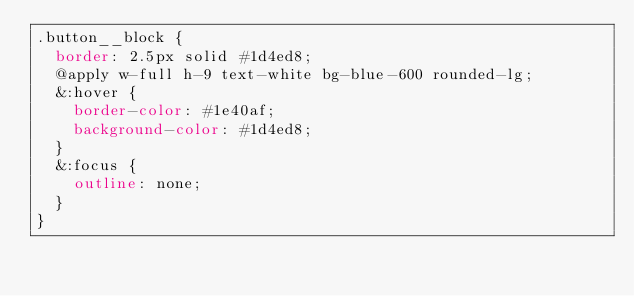<code> <loc_0><loc_0><loc_500><loc_500><_CSS_>.button__block {
  border: 2.5px solid #1d4ed8;
  @apply w-full h-9 text-white bg-blue-600 rounded-lg;
  &:hover {
    border-color: #1e40af;
    background-color: #1d4ed8;
  }
  &:focus {
    outline: none;
  }
}
</code> 